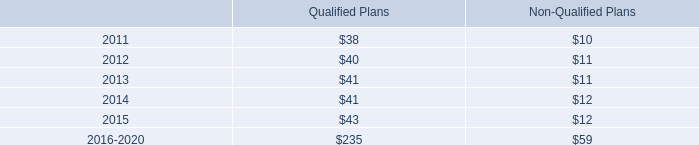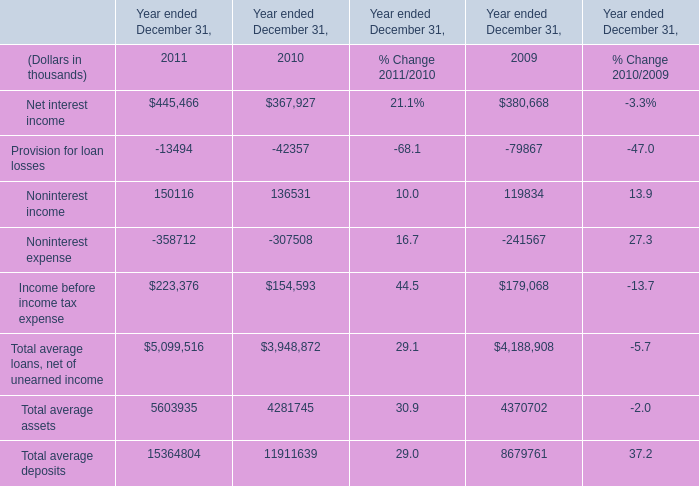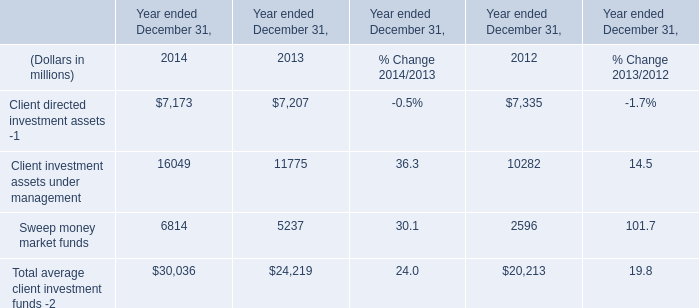What is the average amount of Sweep money market funds of Year ended December 31, 2012, and Net interest income of Year ended December 31, 2009 ? 
Computations: ((2596.0 + 380668.0) / 2)
Answer: 191632.0. 